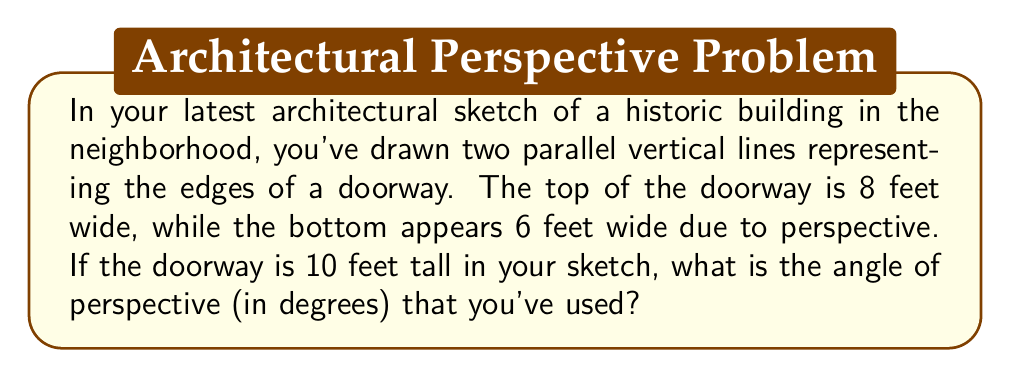Can you solve this math problem? Let's approach this step-by-step:

1) First, we need to visualize the situation. The doorway forms a trapezoid in the sketch due to perspective.

2) We can split this trapezoid into a rectangle (the bottom part) and a triangle (the top part that creates the perspective effect).

3) Let's focus on this triangle. We know:
   - The base of the triangle is the difference between the top and bottom widths: 8 - 6 = 2 feet
   - The height of the triangle is the height of the doorway: 10 feet

4) We can use the tangent function to find the angle. The tangent of the angle is the opposite side (half of the base) divided by the adjacent side (height):

   $$\tan(\theta) = \frac{\text{opposite}}{\text{adjacent}} = \frac{1}{10}$$

5) To find the angle, we need to use the inverse tangent (arctan or $\tan^{-1}$):

   $$\theta = \tan^{-1}(\frac{1}{10})$$

6) Using a calculator or computer:

   $$\theta \approx 5.71°$$

7) This is the angle for one side. Since the perspective is symmetrical, the total angle of perspective is twice this:

   $$\text{Total angle} = 2 * 5.71° \approx 11.42°$$
Answer: $11.42°$ 